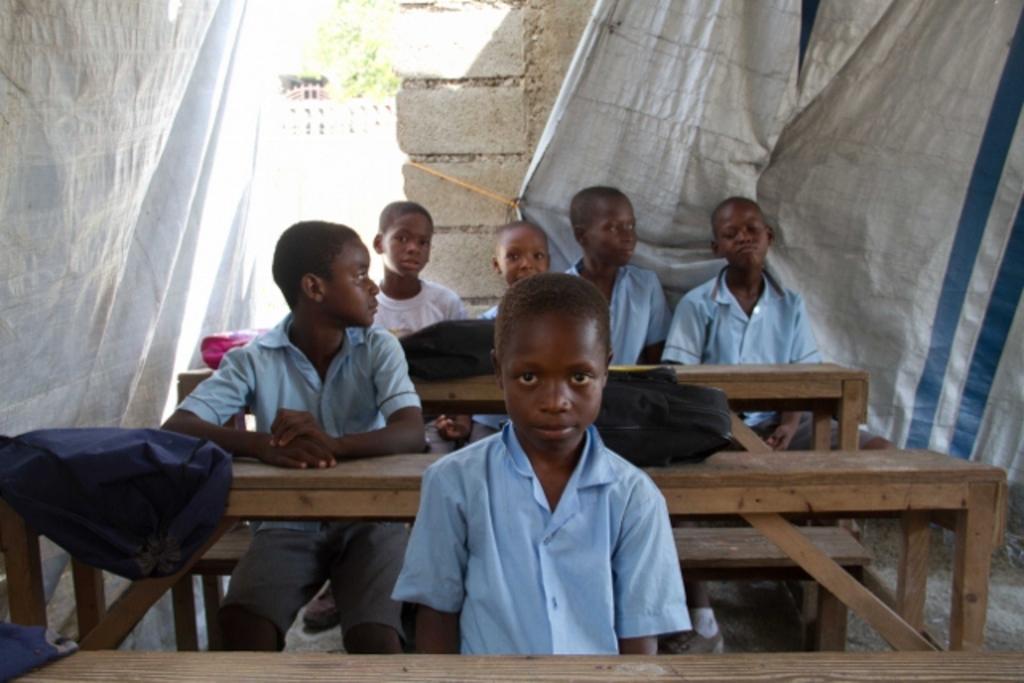Could you give a brief overview of what you see in this image? In this image there are group of sitting on the benches. At the left and at the right there is a sheet and at the back there is a wall and there is a tree. There are bags on the table. 